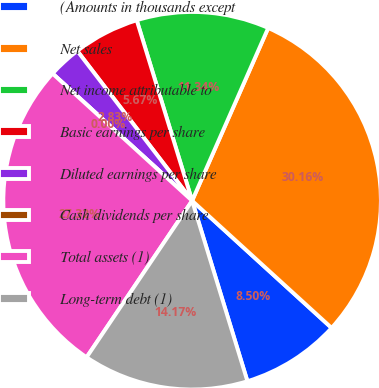Convert chart. <chart><loc_0><loc_0><loc_500><loc_500><pie_chart><fcel>(Amounts in thousands except<fcel>Net sales<fcel>Net income attributable to<fcel>Basic earnings per share<fcel>Diluted earnings per share<fcel>Cash dividends per share<fcel>Total assets (1)<fcel>Long-term debt (1)<nl><fcel>8.5%<fcel>30.16%<fcel>11.34%<fcel>5.67%<fcel>2.83%<fcel>0.0%<fcel>27.32%<fcel>14.17%<nl></chart> 